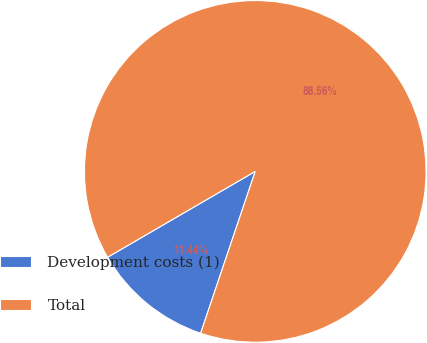Convert chart. <chart><loc_0><loc_0><loc_500><loc_500><pie_chart><fcel>Development costs (1)<fcel>Total<nl><fcel>11.44%<fcel>88.56%<nl></chart> 